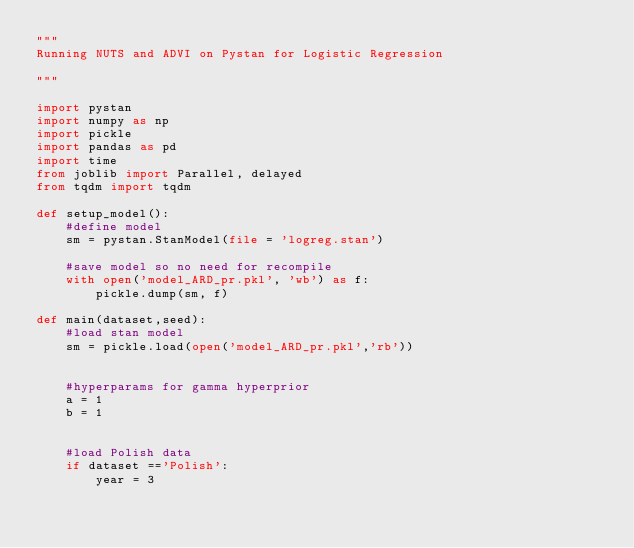<code> <loc_0><loc_0><loc_500><loc_500><_Python_>""" 
Running NUTS and ADVI on Pystan for Logistic Regression

"""

import pystan
import numpy as np
import pickle
import pandas as pd
import time
from joblib import Parallel, delayed
from tqdm import tqdm

def setup_model():
    #define model
    sm = pystan.StanModel(file = 'logreg.stan')

    #save model so no need for recompile
    with open('model_ARD_pr.pkl', 'wb') as f:
        pickle.dump(sm, f)

def main(dataset,seed):
    #load stan model
    sm = pickle.load(open('model_ARD_pr.pkl','rb'))


    #hyperparams for gamma hyperprior
    a = 1
    b = 1


    #load Polish data
    if dataset =='Polish':
        year = 3</code> 